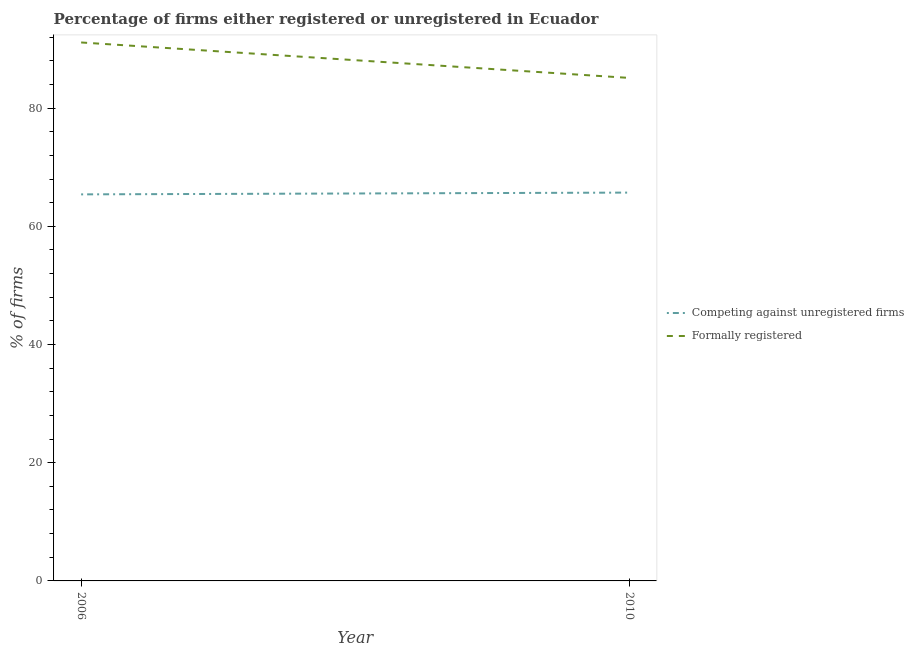Does the line corresponding to percentage of formally registered firms intersect with the line corresponding to percentage of registered firms?
Your response must be concise. No. Is the number of lines equal to the number of legend labels?
Keep it short and to the point. Yes. What is the percentage of formally registered firms in 2006?
Your response must be concise. 91.1. Across all years, what is the maximum percentage of formally registered firms?
Offer a terse response. 91.1. Across all years, what is the minimum percentage of formally registered firms?
Make the answer very short. 85.1. In which year was the percentage of registered firms maximum?
Your answer should be very brief. 2010. What is the total percentage of formally registered firms in the graph?
Provide a short and direct response. 176.2. What is the difference between the percentage of registered firms in 2006 and that in 2010?
Give a very brief answer. -0.3. What is the difference between the percentage of registered firms in 2006 and the percentage of formally registered firms in 2010?
Provide a short and direct response. -19.7. What is the average percentage of registered firms per year?
Provide a short and direct response. 65.55. In the year 2006, what is the difference between the percentage of registered firms and percentage of formally registered firms?
Provide a succinct answer. -25.7. What is the ratio of the percentage of registered firms in 2006 to that in 2010?
Provide a succinct answer. 1. In how many years, is the percentage of registered firms greater than the average percentage of registered firms taken over all years?
Offer a very short reply. 1. Does the percentage of registered firms monotonically increase over the years?
Provide a succinct answer. Yes. Is the percentage of formally registered firms strictly greater than the percentage of registered firms over the years?
Your answer should be very brief. Yes. How many years are there in the graph?
Give a very brief answer. 2. What is the difference between two consecutive major ticks on the Y-axis?
Provide a succinct answer. 20. Are the values on the major ticks of Y-axis written in scientific E-notation?
Give a very brief answer. No. Does the graph contain any zero values?
Offer a terse response. No. Where does the legend appear in the graph?
Give a very brief answer. Center right. How are the legend labels stacked?
Offer a very short reply. Vertical. What is the title of the graph?
Keep it short and to the point. Percentage of firms either registered or unregistered in Ecuador. What is the label or title of the X-axis?
Provide a short and direct response. Year. What is the label or title of the Y-axis?
Keep it short and to the point. % of firms. What is the % of firms in Competing against unregistered firms in 2006?
Keep it short and to the point. 65.4. What is the % of firms of Formally registered in 2006?
Give a very brief answer. 91.1. What is the % of firms of Competing against unregistered firms in 2010?
Provide a short and direct response. 65.7. What is the % of firms of Formally registered in 2010?
Provide a short and direct response. 85.1. Across all years, what is the maximum % of firms in Competing against unregistered firms?
Keep it short and to the point. 65.7. Across all years, what is the maximum % of firms of Formally registered?
Make the answer very short. 91.1. Across all years, what is the minimum % of firms in Competing against unregistered firms?
Offer a very short reply. 65.4. Across all years, what is the minimum % of firms in Formally registered?
Give a very brief answer. 85.1. What is the total % of firms in Competing against unregistered firms in the graph?
Ensure brevity in your answer.  131.1. What is the total % of firms of Formally registered in the graph?
Give a very brief answer. 176.2. What is the difference between the % of firms in Competing against unregistered firms in 2006 and that in 2010?
Make the answer very short. -0.3. What is the difference between the % of firms of Competing against unregistered firms in 2006 and the % of firms of Formally registered in 2010?
Provide a short and direct response. -19.7. What is the average % of firms in Competing against unregistered firms per year?
Your answer should be compact. 65.55. What is the average % of firms of Formally registered per year?
Your answer should be very brief. 88.1. In the year 2006, what is the difference between the % of firms of Competing against unregistered firms and % of firms of Formally registered?
Your answer should be very brief. -25.7. In the year 2010, what is the difference between the % of firms in Competing against unregistered firms and % of firms in Formally registered?
Ensure brevity in your answer.  -19.4. What is the ratio of the % of firms of Formally registered in 2006 to that in 2010?
Offer a terse response. 1.07. What is the difference between the highest and the second highest % of firms of Competing against unregistered firms?
Provide a short and direct response. 0.3. What is the difference between the highest and the second highest % of firms in Formally registered?
Make the answer very short. 6. What is the difference between the highest and the lowest % of firms of Competing against unregistered firms?
Make the answer very short. 0.3. 